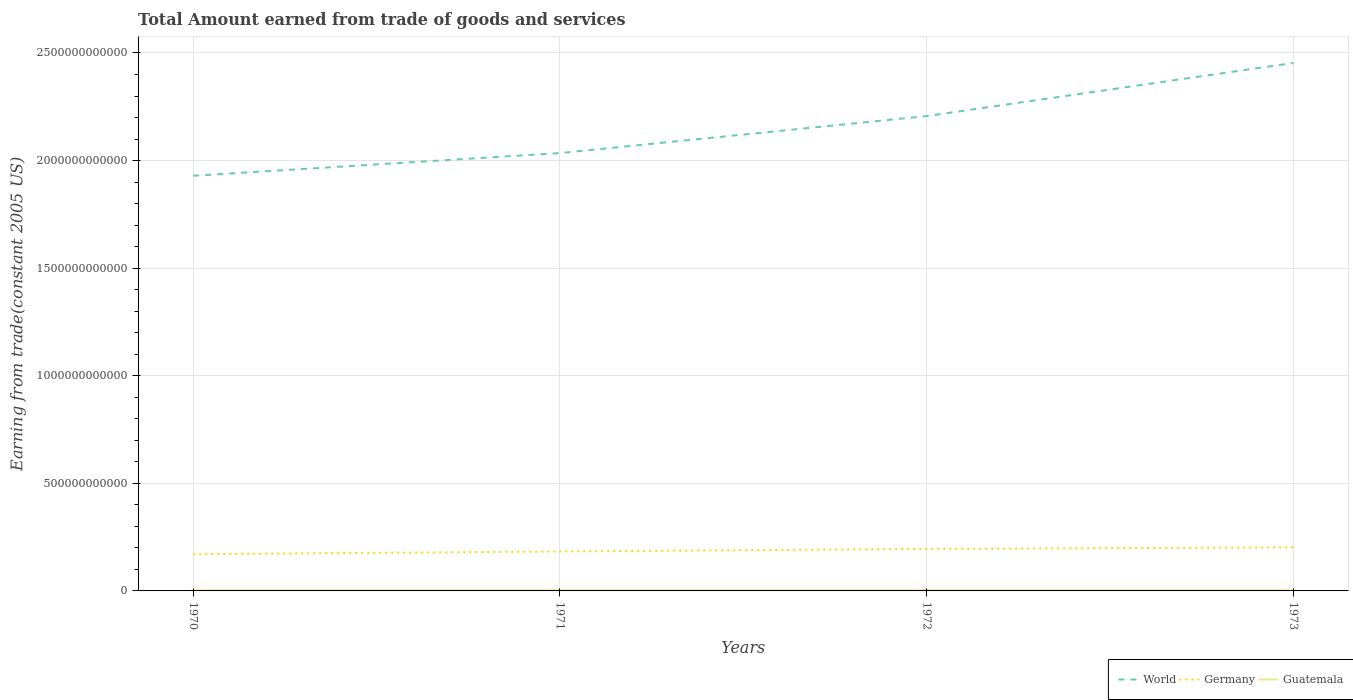How many different coloured lines are there?
Keep it short and to the point. 3. Across all years, what is the maximum total amount earned by trading goods and services in World?
Your response must be concise. 1.93e+12. In which year was the total amount earned by trading goods and services in Germany maximum?
Make the answer very short. 1970. What is the total total amount earned by trading goods and services in Guatemala in the graph?
Provide a short and direct response. 1.91e+08. What is the difference between the highest and the second highest total amount earned by trading goods and services in Guatemala?
Provide a short and direct response. 3.40e+08. What is the difference between the highest and the lowest total amount earned by trading goods and services in Guatemala?
Your answer should be very brief. 2. Is the total amount earned by trading goods and services in Germany strictly greater than the total amount earned by trading goods and services in Guatemala over the years?
Give a very brief answer. No. How many lines are there?
Give a very brief answer. 3. What is the difference between two consecutive major ticks on the Y-axis?
Provide a short and direct response. 5.00e+11. Are the values on the major ticks of Y-axis written in scientific E-notation?
Offer a very short reply. No. Does the graph contain any zero values?
Ensure brevity in your answer.  No. Where does the legend appear in the graph?
Give a very brief answer. Bottom right. How many legend labels are there?
Ensure brevity in your answer.  3. How are the legend labels stacked?
Ensure brevity in your answer.  Horizontal. What is the title of the graph?
Provide a short and direct response. Total Amount earned from trade of goods and services. What is the label or title of the Y-axis?
Your response must be concise. Earning from trade(constant 2005 US). What is the Earning from trade(constant 2005 US) in World in 1970?
Provide a short and direct response. 1.93e+12. What is the Earning from trade(constant 2005 US) of Germany in 1970?
Keep it short and to the point. 1.71e+11. What is the Earning from trade(constant 2005 US) of Guatemala in 1970?
Offer a very short reply. 3.22e+09. What is the Earning from trade(constant 2005 US) of World in 1971?
Offer a terse response. 2.03e+12. What is the Earning from trade(constant 2005 US) in Germany in 1971?
Your response must be concise. 1.83e+11. What is the Earning from trade(constant 2005 US) of Guatemala in 1971?
Offer a terse response. 3.43e+09. What is the Earning from trade(constant 2005 US) in World in 1972?
Provide a short and direct response. 2.21e+12. What is the Earning from trade(constant 2005 US) in Germany in 1972?
Offer a terse response. 1.95e+11. What is the Earning from trade(constant 2005 US) of Guatemala in 1972?
Keep it short and to the point. 3.24e+09. What is the Earning from trade(constant 2005 US) in World in 1973?
Your response must be concise. 2.45e+12. What is the Earning from trade(constant 2005 US) of Germany in 1973?
Provide a short and direct response. 2.02e+11. What is the Earning from trade(constant 2005 US) in Guatemala in 1973?
Provide a short and direct response. 3.56e+09. Across all years, what is the maximum Earning from trade(constant 2005 US) of World?
Your answer should be very brief. 2.45e+12. Across all years, what is the maximum Earning from trade(constant 2005 US) of Germany?
Offer a terse response. 2.02e+11. Across all years, what is the maximum Earning from trade(constant 2005 US) in Guatemala?
Provide a succinct answer. 3.56e+09. Across all years, what is the minimum Earning from trade(constant 2005 US) in World?
Ensure brevity in your answer.  1.93e+12. Across all years, what is the minimum Earning from trade(constant 2005 US) of Germany?
Ensure brevity in your answer.  1.71e+11. Across all years, what is the minimum Earning from trade(constant 2005 US) in Guatemala?
Your answer should be compact. 3.22e+09. What is the total Earning from trade(constant 2005 US) of World in the graph?
Offer a very short reply. 8.63e+12. What is the total Earning from trade(constant 2005 US) of Germany in the graph?
Your response must be concise. 7.52e+11. What is the total Earning from trade(constant 2005 US) in Guatemala in the graph?
Offer a very short reply. 1.35e+1. What is the difference between the Earning from trade(constant 2005 US) in World in 1970 and that in 1971?
Offer a terse response. -1.06e+11. What is the difference between the Earning from trade(constant 2005 US) in Germany in 1970 and that in 1971?
Your answer should be compact. -1.26e+1. What is the difference between the Earning from trade(constant 2005 US) in Guatemala in 1970 and that in 1971?
Provide a succinct answer. -2.07e+08. What is the difference between the Earning from trade(constant 2005 US) of World in 1970 and that in 1972?
Make the answer very short. -2.78e+11. What is the difference between the Earning from trade(constant 2005 US) of Germany in 1970 and that in 1972?
Your response must be concise. -2.45e+1. What is the difference between the Earning from trade(constant 2005 US) in Guatemala in 1970 and that in 1972?
Give a very brief answer. -1.54e+07. What is the difference between the Earning from trade(constant 2005 US) in World in 1970 and that in 1973?
Offer a very short reply. -5.24e+11. What is the difference between the Earning from trade(constant 2005 US) in Germany in 1970 and that in 1973?
Keep it short and to the point. -3.16e+1. What is the difference between the Earning from trade(constant 2005 US) of Guatemala in 1970 and that in 1973?
Offer a terse response. -3.40e+08. What is the difference between the Earning from trade(constant 2005 US) of World in 1971 and that in 1972?
Your answer should be very brief. -1.72e+11. What is the difference between the Earning from trade(constant 2005 US) in Germany in 1971 and that in 1972?
Ensure brevity in your answer.  -1.19e+1. What is the difference between the Earning from trade(constant 2005 US) in Guatemala in 1971 and that in 1972?
Provide a succinct answer. 1.91e+08. What is the difference between the Earning from trade(constant 2005 US) of World in 1971 and that in 1973?
Make the answer very short. -4.19e+11. What is the difference between the Earning from trade(constant 2005 US) in Germany in 1971 and that in 1973?
Your response must be concise. -1.90e+1. What is the difference between the Earning from trade(constant 2005 US) of Guatemala in 1971 and that in 1973?
Your response must be concise. -1.33e+08. What is the difference between the Earning from trade(constant 2005 US) of World in 1972 and that in 1973?
Ensure brevity in your answer.  -2.47e+11. What is the difference between the Earning from trade(constant 2005 US) in Germany in 1972 and that in 1973?
Offer a terse response. -7.12e+09. What is the difference between the Earning from trade(constant 2005 US) in Guatemala in 1972 and that in 1973?
Ensure brevity in your answer.  -3.24e+08. What is the difference between the Earning from trade(constant 2005 US) of World in 1970 and the Earning from trade(constant 2005 US) of Germany in 1971?
Your answer should be very brief. 1.75e+12. What is the difference between the Earning from trade(constant 2005 US) of World in 1970 and the Earning from trade(constant 2005 US) of Guatemala in 1971?
Provide a short and direct response. 1.93e+12. What is the difference between the Earning from trade(constant 2005 US) in Germany in 1970 and the Earning from trade(constant 2005 US) in Guatemala in 1971?
Your answer should be very brief. 1.67e+11. What is the difference between the Earning from trade(constant 2005 US) in World in 1970 and the Earning from trade(constant 2005 US) in Germany in 1972?
Offer a very short reply. 1.73e+12. What is the difference between the Earning from trade(constant 2005 US) of World in 1970 and the Earning from trade(constant 2005 US) of Guatemala in 1972?
Give a very brief answer. 1.93e+12. What is the difference between the Earning from trade(constant 2005 US) of Germany in 1970 and the Earning from trade(constant 2005 US) of Guatemala in 1972?
Make the answer very short. 1.67e+11. What is the difference between the Earning from trade(constant 2005 US) of World in 1970 and the Earning from trade(constant 2005 US) of Germany in 1973?
Your answer should be compact. 1.73e+12. What is the difference between the Earning from trade(constant 2005 US) in World in 1970 and the Earning from trade(constant 2005 US) in Guatemala in 1973?
Make the answer very short. 1.93e+12. What is the difference between the Earning from trade(constant 2005 US) in Germany in 1970 and the Earning from trade(constant 2005 US) in Guatemala in 1973?
Your answer should be very brief. 1.67e+11. What is the difference between the Earning from trade(constant 2005 US) of World in 1971 and the Earning from trade(constant 2005 US) of Germany in 1972?
Your answer should be compact. 1.84e+12. What is the difference between the Earning from trade(constant 2005 US) in World in 1971 and the Earning from trade(constant 2005 US) in Guatemala in 1972?
Offer a terse response. 2.03e+12. What is the difference between the Earning from trade(constant 2005 US) of Germany in 1971 and the Earning from trade(constant 2005 US) of Guatemala in 1972?
Ensure brevity in your answer.  1.80e+11. What is the difference between the Earning from trade(constant 2005 US) of World in 1971 and the Earning from trade(constant 2005 US) of Germany in 1973?
Keep it short and to the point. 1.83e+12. What is the difference between the Earning from trade(constant 2005 US) in World in 1971 and the Earning from trade(constant 2005 US) in Guatemala in 1973?
Offer a very short reply. 2.03e+12. What is the difference between the Earning from trade(constant 2005 US) of Germany in 1971 and the Earning from trade(constant 2005 US) of Guatemala in 1973?
Your response must be concise. 1.80e+11. What is the difference between the Earning from trade(constant 2005 US) in World in 1972 and the Earning from trade(constant 2005 US) in Germany in 1973?
Provide a succinct answer. 2.00e+12. What is the difference between the Earning from trade(constant 2005 US) in World in 1972 and the Earning from trade(constant 2005 US) in Guatemala in 1973?
Provide a short and direct response. 2.20e+12. What is the difference between the Earning from trade(constant 2005 US) in Germany in 1972 and the Earning from trade(constant 2005 US) in Guatemala in 1973?
Ensure brevity in your answer.  1.92e+11. What is the average Earning from trade(constant 2005 US) in World per year?
Give a very brief answer. 2.16e+12. What is the average Earning from trade(constant 2005 US) in Germany per year?
Provide a succinct answer. 1.88e+11. What is the average Earning from trade(constant 2005 US) in Guatemala per year?
Keep it short and to the point. 3.36e+09. In the year 1970, what is the difference between the Earning from trade(constant 2005 US) of World and Earning from trade(constant 2005 US) of Germany?
Offer a terse response. 1.76e+12. In the year 1970, what is the difference between the Earning from trade(constant 2005 US) in World and Earning from trade(constant 2005 US) in Guatemala?
Provide a succinct answer. 1.93e+12. In the year 1970, what is the difference between the Earning from trade(constant 2005 US) in Germany and Earning from trade(constant 2005 US) in Guatemala?
Provide a succinct answer. 1.68e+11. In the year 1971, what is the difference between the Earning from trade(constant 2005 US) of World and Earning from trade(constant 2005 US) of Germany?
Provide a succinct answer. 1.85e+12. In the year 1971, what is the difference between the Earning from trade(constant 2005 US) of World and Earning from trade(constant 2005 US) of Guatemala?
Your answer should be very brief. 2.03e+12. In the year 1971, what is the difference between the Earning from trade(constant 2005 US) in Germany and Earning from trade(constant 2005 US) in Guatemala?
Your answer should be compact. 1.80e+11. In the year 1972, what is the difference between the Earning from trade(constant 2005 US) in World and Earning from trade(constant 2005 US) in Germany?
Offer a terse response. 2.01e+12. In the year 1972, what is the difference between the Earning from trade(constant 2005 US) in World and Earning from trade(constant 2005 US) in Guatemala?
Offer a terse response. 2.20e+12. In the year 1972, what is the difference between the Earning from trade(constant 2005 US) in Germany and Earning from trade(constant 2005 US) in Guatemala?
Offer a terse response. 1.92e+11. In the year 1973, what is the difference between the Earning from trade(constant 2005 US) in World and Earning from trade(constant 2005 US) in Germany?
Ensure brevity in your answer.  2.25e+12. In the year 1973, what is the difference between the Earning from trade(constant 2005 US) of World and Earning from trade(constant 2005 US) of Guatemala?
Ensure brevity in your answer.  2.45e+12. In the year 1973, what is the difference between the Earning from trade(constant 2005 US) of Germany and Earning from trade(constant 2005 US) of Guatemala?
Offer a terse response. 1.99e+11. What is the ratio of the Earning from trade(constant 2005 US) of World in 1970 to that in 1971?
Ensure brevity in your answer.  0.95. What is the ratio of the Earning from trade(constant 2005 US) in Germany in 1970 to that in 1971?
Provide a short and direct response. 0.93. What is the ratio of the Earning from trade(constant 2005 US) of Guatemala in 1970 to that in 1971?
Offer a terse response. 0.94. What is the ratio of the Earning from trade(constant 2005 US) of World in 1970 to that in 1972?
Your response must be concise. 0.87. What is the ratio of the Earning from trade(constant 2005 US) in Germany in 1970 to that in 1972?
Your answer should be compact. 0.87. What is the ratio of the Earning from trade(constant 2005 US) of World in 1970 to that in 1973?
Offer a very short reply. 0.79. What is the ratio of the Earning from trade(constant 2005 US) in Germany in 1970 to that in 1973?
Keep it short and to the point. 0.84. What is the ratio of the Earning from trade(constant 2005 US) of Guatemala in 1970 to that in 1973?
Ensure brevity in your answer.  0.9. What is the ratio of the Earning from trade(constant 2005 US) in World in 1971 to that in 1972?
Offer a very short reply. 0.92. What is the ratio of the Earning from trade(constant 2005 US) in Germany in 1971 to that in 1972?
Make the answer very short. 0.94. What is the ratio of the Earning from trade(constant 2005 US) in Guatemala in 1971 to that in 1972?
Keep it short and to the point. 1.06. What is the ratio of the Earning from trade(constant 2005 US) of World in 1971 to that in 1973?
Make the answer very short. 0.83. What is the ratio of the Earning from trade(constant 2005 US) of Germany in 1971 to that in 1973?
Provide a short and direct response. 0.91. What is the ratio of the Earning from trade(constant 2005 US) in Guatemala in 1971 to that in 1973?
Provide a short and direct response. 0.96. What is the ratio of the Earning from trade(constant 2005 US) of World in 1972 to that in 1973?
Offer a terse response. 0.9. What is the ratio of the Earning from trade(constant 2005 US) in Germany in 1972 to that in 1973?
Keep it short and to the point. 0.96. What is the ratio of the Earning from trade(constant 2005 US) in Guatemala in 1972 to that in 1973?
Offer a very short reply. 0.91. What is the difference between the highest and the second highest Earning from trade(constant 2005 US) of World?
Give a very brief answer. 2.47e+11. What is the difference between the highest and the second highest Earning from trade(constant 2005 US) of Germany?
Provide a succinct answer. 7.12e+09. What is the difference between the highest and the second highest Earning from trade(constant 2005 US) of Guatemala?
Your answer should be very brief. 1.33e+08. What is the difference between the highest and the lowest Earning from trade(constant 2005 US) of World?
Provide a succinct answer. 5.24e+11. What is the difference between the highest and the lowest Earning from trade(constant 2005 US) in Germany?
Your answer should be compact. 3.16e+1. What is the difference between the highest and the lowest Earning from trade(constant 2005 US) in Guatemala?
Make the answer very short. 3.40e+08. 